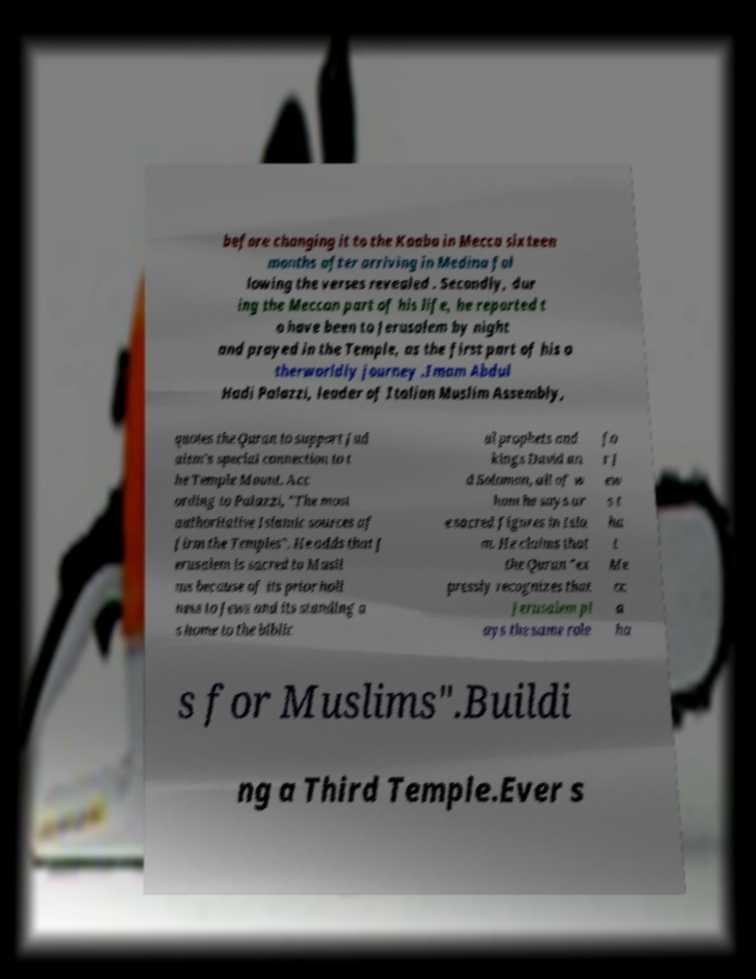There's text embedded in this image that I need extracted. Can you transcribe it verbatim? before changing it to the Kaaba in Mecca sixteen months after arriving in Medina fol lowing the verses revealed . Secondly, dur ing the Meccan part of his life, he reported t o have been to Jerusalem by night and prayed in the Temple, as the first part of his o therworldly journey .Imam Abdul Hadi Palazzi, leader of Italian Muslim Assembly, quotes the Quran to support Jud aism's special connection to t he Temple Mount. Acc ording to Palazzi, "The most authoritative Islamic sources af firm the Temples". He adds that J erusalem is sacred to Musli ms because of its prior holi ness to Jews and its standing a s home to the biblic al prophets and kings David an d Solomon, all of w hom he says ar e sacred figures in Isla m. He claims that the Quran "ex pressly recognizes that Jerusalem pl ays the same role fo r J ew s t ha t Me cc a ha s for Muslims".Buildi ng a Third Temple.Ever s 